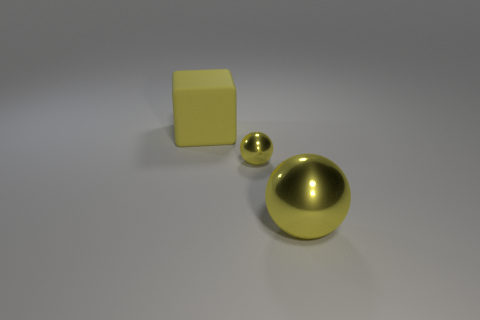Subtract all yellow balls. How many were subtracted if there are1yellow balls left? 1 Add 2 large red metal objects. How many objects exist? 5 Subtract all cubes. How many objects are left? 2 Subtract 0 cyan cubes. How many objects are left? 3 Subtract all yellow matte cubes. Subtract all big yellow metal things. How many objects are left? 1 Add 3 large shiny things. How many large shiny things are left? 4 Add 2 small spheres. How many small spheres exist? 3 